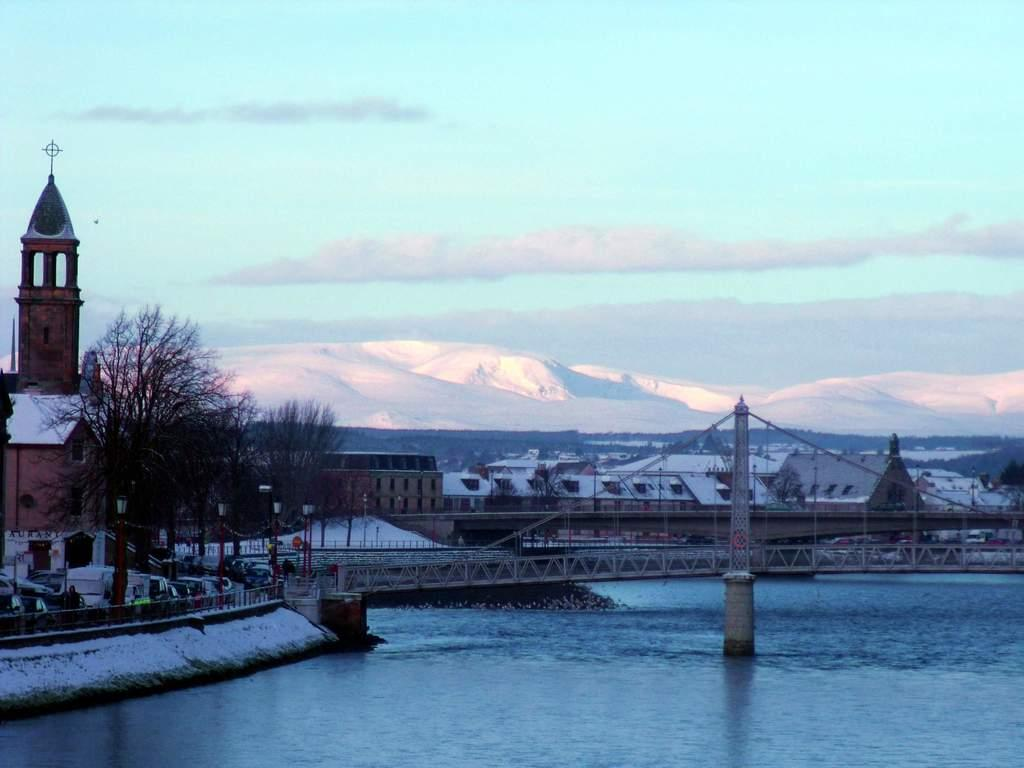What structure can be seen in the image? There is a bridge in the image. What is visible beneath the bridge? Water is visible in the image. What can be seen on the left side of the bridge? There are poles with lights on the left side of the bridge. What is visible behind the bridge? There are trees, buildings, and hills behind the bridge. What part of the natural environment is visible in the image? The sky is visible in the image. What type of potato is being used to build the bridge in the image? There is no potato present in the image, and the bridge is not being built. 